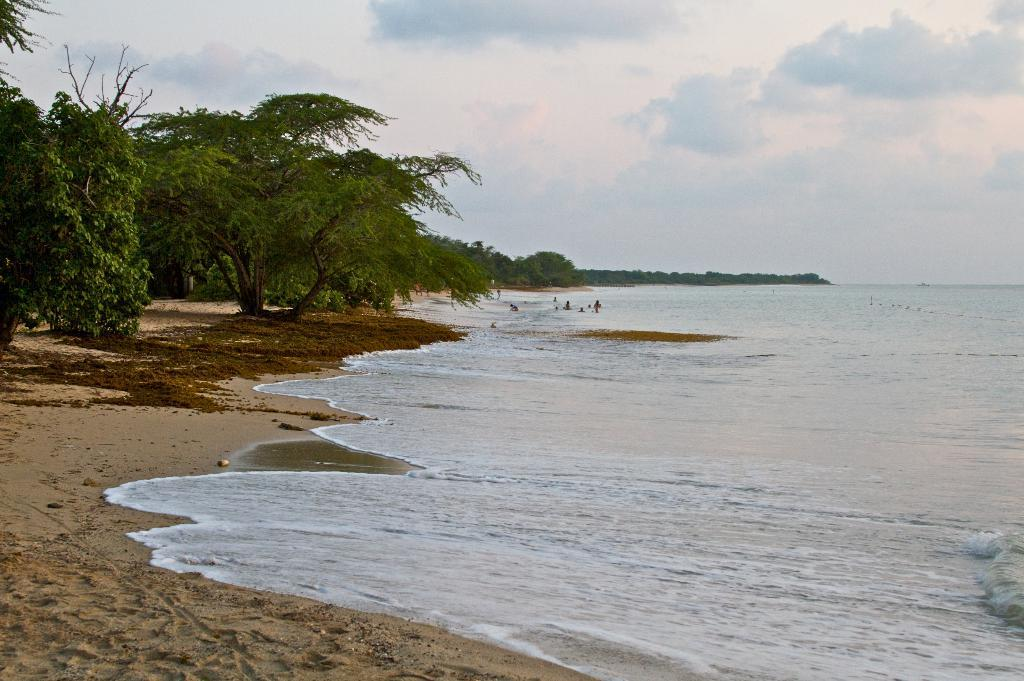What can be seen on the right side of the image? There is water on the right side of the image. What is located on the left side of the image? There are trees on the left side of the image. What is visible in the sky at the top of the image? There are clouds visible in the sky at the top of the image. How many clocks are hanging from the trees on the left side of the image? There are no clocks hanging from the trees in the image; only trees are present. What type of debt is being discussed in the image? There is no mention of debt in the image; it features water, trees, and clouds. 